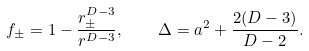<formula> <loc_0><loc_0><loc_500><loc_500>f _ { \pm } = 1 - \frac { r _ { \pm } ^ { D - 3 } } { r ^ { D - 3 } } , \quad \Delta = a ^ { 2 } + \frac { 2 ( D - 3 ) } { D - 2 } .</formula> 